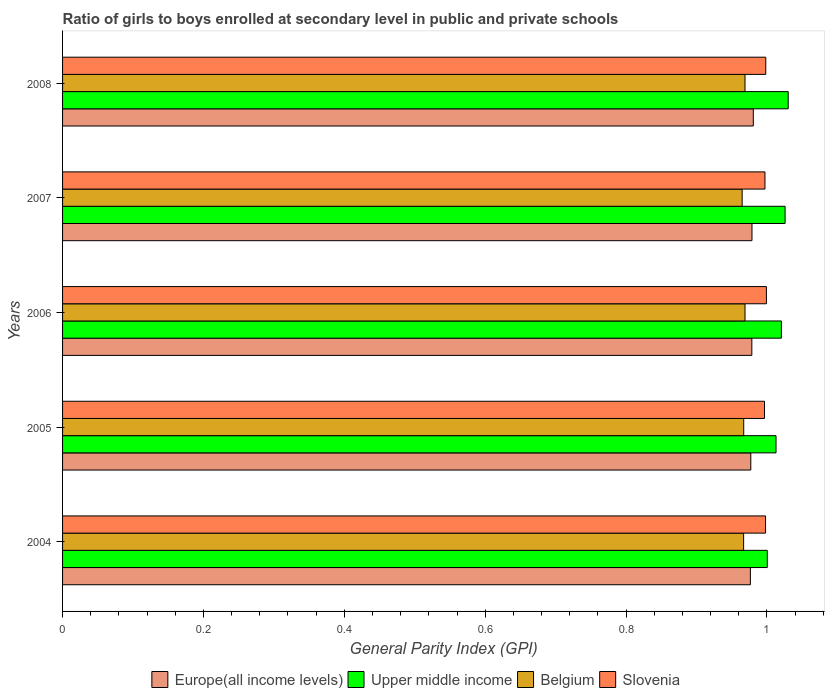How many groups of bars are there?
Keep it short and to the point. 5. Are the number of bars per tick equal to the number of legend labels?
Ensure brevity in your answer.  Yes. Are the number of bars on each tick of the Y-axis equal?
Offer a very short reply. Yes. What is the general parity index in Upper middle income in 2004?
Make the answer very short. 1. Across all years, what is the maximum general parity index in Slovenia?
Keep it short and to the point. 1. Across all years, what is the minimum general parity index in Upper middle income?
Keep it short and to the point. 1. In which year was the general parity index in Europe(all income levels) maximum?
Offer a terse response. 2008. In which year was the general parity index in Slovenia minimum?
Make the answer very short. 2005. What is the total general parity index in Slovenia in the graph?
Offer a very short reply. 4.99. What is the difference between the general parity index in Europe(all income levels) in 2004 and that in 2006?
Your response must be concise. -0. What is the difference between the general parity index in Europe(all income levels) in 2004 and the general parity index in Belgium in 2008?
Give a very brief answer. 0.01. What is the average general parity index in Europe(all income levels) per year?
Make the answer very short. 0.98. In the year 2006, what is the difference between the general parity index in Slovenia and general parity index in Upper middle income?
Offer a terse response. -0.02. In how many years, is the general parity index in Upper middle income greater than 0.48000000000000004 ?
Your answer should be very brief. 5. What is the ratio of the general parity index in Upper middle income in 2004 to that in 2006?
Your response must be concise. 0.98. What is the difference between the highest and the second highest general parity index in Belgium?
Your answer should be compact. 1.996755599986688e-5. What is the difference between the highest and the lowest general parity index in Slovenia?
Give a very brief answer. 0. Is the sum of the general parity index in Europe(all income levels) in 2005 and 2006 greater than the maximum general parity index in Belgium across all years?
Offer a terse response. Yes. Is it the case that in every year, the sum of the general parity index in Belgium and general parity index in Upper middle income is greater than the sum of general parity index in Slovenia and general parity index in Europe(all income levels)?
Give a very brief answer. No. What does the 1st bar from the top in 2008 represents?
Give a very brief answer. Slovenia. What does the 3rd bar from the bottom in 2006 represents?
Offer a terse response. Belgium. Is it the case that in every year, the sum of the general parity index in Slovenia and general parity index in Upper middle income is greater than the general parity index in Europe(all income levels)?
Your answer should be very brief. Yes. How are the legend labels stacked?
Provide a short and direct response. Horizontal. What is the title of the graph?
Provide a short and direct response. Ratio of girls to boys enrolled at secondary level in public and private schools. Does "Uzbekistan" appear as one of the legend labels in the graph?
Provide a succinct answer. No. What is the label or title of the X-axis?
Offer a terse response. General Parity Index (GPI). What is the label or title of the Y-axis?
Provide a succinct answer. Years. What is the General Parity Index (GPI) in Europe(all income levels) in 2004?
Provide a succinct answer. 0.98. What is the General Parity Index (GPI) in Upper middle income in 2004?
Make the answer very short. 1. What is the General Parity Index (GPI) in Belgium in 2004?
Offer a terse response. 0.97. What is the General Parity Index (GPI) of Slovenia in 2004?
Offer a very short reply. 1. What is the General Parity Index (GPI) in Europe(all income levels) in 2005?
Offer a very short reply. 0.98. What is the General Parity Index (GPI) in Upper middle income in 2005?
Your answer should be very brief. 1.01. What is the General Parity Index (GPI) in Belgium in 2005?
Give a very brief answer. 0.97. What is the General Parity Index (GPI) in Slovenia in 2005?
Provide a short and direct response. 1. What is the General Parity Index (GPI) of Europe(all income levels) in 2006?
Offer a terse response. 0.98. What is the General Parity Index (GPI) in Upper middle income in 2006?
Offer a terse response. 1.02. What is the General Parity Index (GPI) in Belgium in 2006?
Provide a succinct answer. 0.97. What is the General Parity Index (GPI) of Slovenia in 2006?
Your response must be concise. 1. What is the General Parity Index (GPI) in Europe(all income levels) in 2007?
Your response must be concise. 0.98. What is the General Parity Index (GPI) in Upper middle income in 2007?
Make the answer very short. 1.03. What is the General Parity Index (GPI) in Belgium in 2007?
Your response must be concise. 0.96. What is the General Parity Index (GPI) in Slovenia in 2007?
Ensure brevity in your answer.  1. What is the General Parity Index (GPI) in Europe(all income levels) in 2008?
Offer a very short reply. 0.98. What is the General Parity Index (GPI) in Upper middle income in 2008?
Make the answer very short. 1.03. What is the General Parity Index (GPI) of Belgium in 2008?
Your answer should be compact. 0.97. What is the General Parity Index (GPI) of Slovenia in 2008?
Keep it short and to the point. 1. Across all years, what is the maximum General Parity Index (GPI) of Europe(all income levels)?
Make the answer very short. 0.98. Across all years, what is the maximum General Parity Index (GPI) of Upper middle income?
Make the answer very short. 1.03. Across all years, what is the maximum General Parity Index (GPI) in Belgium?
Your answer should be compact. 0.97. Across all years, what is the maximum General Parity Index (GPI) of Slovenia?
Keep it short and to the point. 1. Across all years, what is the minimum General Parity Index (GPI) of Europe(all income levels)?
Offer a terse response. 0.98. Across all years, what is the minimum General Parity Index (GPI) of Upper middle income?
Provide a short and direct response. 1. Across all years, what is the minimum General Parity Index (GPI) of Belgium?
Offer a terse response. 0.96. Across all years, what is the minimum General Parity Index (GPI) of Slovenia?
Make the answer very short. 1. What is the total General Parity Index (GPI) in Europe(all income levels) in the graph?
Make the answer very short. 4.89. What is the total General Parity Index (GPI) of Upper middle income in the graph?
Ensure brevity in your answer.  5.09. What is the total General Parity Index (GPI) in Belgium in the graph?
Your answer should be very brief. 4.84. What is the total General Parity Index (GPI) in Slovenia in the graph?
Offer a terse response. 4.99. What is the difference between the General Parity Index (GPI) in Europe(all income levels) in 2004 and that in 2005?
Offer a terse response. -0. What is the difference between the General Parity Index (GPI) in Upper middle income in 2004 and that in 2005?
Provide a succinct answer. -0.01. What is the difference between the General Parity Index (GPI) in Belgium in 2004 and that in 2005?
Your response must be concise. -0. What is the difference between the General Parity Index (GPI) in Slovenia in 2004 and that in 2005?
Provide a succinct answer. 0. What is the difference between the General Parity Index (GPI) of Europe(all income levels) in 2004 and that in 2006?
Offer a very short reply. -0. What is the difference between the General Parity Index (GPI) of Upper middle income in 2004 and that in 2006?
Make the answer very short. -0.02. What is the difference between the General Parity Index (GPI) of Belgium in 2004 and that in 2006?
Your answer should be very brief. -0. What is the difference between the General Parity Index (GPI) in Slovenia in 2004 and that in 2006?
Provide a short and direct response. -0. What is the difference between the General Parity Index (GPI) of Europe(all income levels) in 2004 and that in 2007?
Offer a terse response. -0. What is the difference between the General Parity Index (GPI) of Upper middle income in 2004 and that in 2007?
Give a very brief answer. -0.03. What is the difference between the General Parity Index (GPI) of Belgium in 2004 and that in 2007?
Offer a terse response. 0. What is the difference between the General Parity Index (GPI) in Slovenia in 2004 and that in 2007?
Give a very brief answer. 0. What is the difference between the General Parity Index (GPI) in Europe(all income levels) in 2004 and that in 2008?
Offer a terse response. -0. What is the difference between the General Parity Index (GPI) of Upper middle income in 2004 and that in 2008?
Offer a terse response. -0.03. What is the difference between the General Parity Index (GPI) of Belgium in 2004 and that in 2008?
Your answer should be compact. -0. What is the difference between the General Parity Index (GPI) of Slovenia in 2004 and that in 2008?
Your answer should be compact. -0. What is the difference between the General Parity Index (GPI) in Europe(all income levels) in 2005 and that in 2006?
Give a very brief answer. -0. What is the difference between the General Parity Index (GPI) in Upper middle income in 2005 and that in 2006?
Keep it short and to the point. -0.01. What is the difference between the General Parity Index (GPI) in Belgium in 2005 and that in 2006?
Give a very brief answer. -0. What is the difference between the General Parity Index (GPI) of Slovenia in 2005 and that in 2006?
Your answer should be compact. -0. What is the difference between the General Parity Index (GPI) in Europe(all income levels) in 2005 and that in 2007?
Provide a short and direct response. -0. What is the difference between the General Parity Index (GPI) of Upper middle income in 2005 and that in 2007?
Your answer should be compact. -0.01. What is the difference between the General Parity Index (GPI) in Belgium in 2005 and that in 2007?
Keep it short and to the point. 0. What is the difference between the General Parity Index (GPI) of Slovenia in 2005 and that in 2007?
Give a very brief answer. -0. What is the difference between the General Parity Index (GPI) of Europe(all income levels) in 2005 and that in 2008?
Keep it short and to the point. -0. What is the difference between the General Parity Index (GPI) of Upper middle income in 2005 and that in 2008?
Provide a short and direct response. -0.02. What is the difference between the General Parity Index (GPI) in Belgium in 2005 and that in 2008?
Ensure brevity in your answer.  -0. What is the difference between the General Parity Index (GPI) of Slovenia in 2005 and that in 2008?
Keep it short and to the point. -0. What is the difference between the General Parity Index (GPI) in Europe(all income levels) in 2006 and that in 2007?
Keep it short and to the point. -0. What is the difference between the General Parity Index (GPI) in Upper middle income in 2006 and that in 2007?
Ensure brevity in your answer.  -0.01. What is the difference between the General Parity Index (GPI) of Belgium in 2006 and that in 2007?
Your answer should be compact. 0. What is the difference between the General Parity Index (GPI) of Slovenia in 2006 and that in 2007?
Give a very brief answer. 0. What is the difference between the General Parity Index (GPI) in Europe(all income levels) in 2006 and that in 2008?
Make the answer very short. -0. What is the difference between the General Parity Index (GPI) of Upper middle income in 2006 and that in 2008?
Offer a terse response. -0.01. What is the difference between the General Parity Index (GPI) of Belgium in 2006 and that in 2008?
Your answer should be very brief. 0. What is the difference between the General Parity Index (GPI) of Slovenia in 2006 and that in 2008?
Provide a succinct answer. 0. What is the difference between the General Parity Index (GPI) in Europe(all income levels) in 2007 and that in 2008?
Make the answer very short. -0. What is the difference between the General Parity Index (GPI) of Upper middle income in 2007 and that in 2008?
Your answer should be very brief. -0. What is the difference between the General Parity Index (GPI) in Belgium in 2007 and that in 2008?
Provide a short and direct response. -0. What is the difference between the General Parity Index (GPI) in Slovenia in 2007 and that in 2008?
Provide a succinct answer. -0. What is the difference between the General Parity Index (GPI) in Europe(all income levels) in 2004 and the General Parity Index (GPI) in Upper middle income in 2005?
Offer a terse response. -0.04. What is the difference between the General Parity Index (GPI) in Europe(all income levels) in 2004 and the General Parity Index (GPI) in Belgium in 2005?
Your answer should be very brief. 0.01. What is the difference between the General Parity Index (GPI) of Europe(all income levels) in 2004 and the General Parity Index (GPI) of Slovenia in 2005?
Keep it short and to the point. -0.02. What is the difference between the General Parity Index (GPI) in Upper middle income in 2004 and the General Parity Index (GPI) in Belgium in 2005?
Your answer should be very brief. 0.03. What is the difference between the General Parity Index (GPI) of Upper middle income in 2004 and the General Parity Index (GPI) of Slovenia in 2005?
Keep it short and to the point. 0. What is the difference between the General Parity Index (GPI) of Belgium in 2004 and the General Parity Index (GPI) of Slovenia in 2005?
Provide a succinct answer. -0.03. What is the difference between the General Parity Index (GPI) of Europe(all income levels) in 2004 and the General Parity Index (GPI) of Upper middle income in 2006?
Your response must be concise. -0.04. What is the difference between the General Parity Index (GPI) in Europe(all income levels) in 2004 and the General Parity Index (GPI) in Belgium in 2006?
Offer a very short reply. 0.01. What is the difference between the General Parity Index (GPI) of Europe(all income levels) in 2004 and the General Parity Index (GPI) of Slovenia in 2006?
Make the answer very short. -0.02. What is the difference between the General Parity Index (GPI) of Upper middle income in 2004 and the General Parity Index (GPI) of Belgium in 2006?
Ensure brevity in your answer.  0.03. What is the difference between the General Parity Index (GPI) in Upper middle income in 2004 and the General Parity Index (GPI) in Slovenia in 2006?
Your answer should be compact. 0. What is the difference between the General Parity Index (GPI) in Belgium in 2004 and the General Parity Index (GPI) in Slovenia in 2006?
Your response must be concise. -0.03. What is the difference between the General Parity Index (GPI) of Europe(all income levels) in 2004 and the General Parity Index (GPI) of Upper middle income in 2007?
Your answer should be compact. -0.05. What is the difference between the General Parity Index (GPI) of Europe(all income levels) in 2004 and the General Parity Index (GPI) of Belgium in 2007?
Your answer should be compact. 0.01. What is the difference between the General Parity Index (GPI) in Europe(all income levels) in 2004 and the General Parity Index (GPI) in Slovenia in 2007?
Provide a short and direct response. -0.02. What is the difference between the General Parity Index (GPI) of Upper middle income in 2004 and the General Parity Index (GPI) of Belgium in 2007?
Give a very brief answer. 0.04. What is the difference between the General Parity Index (GPI) of Upper middle income in 2004 and the General Parity Index (GPI) of Slovenia in 2007?
Provide a short and direct response. 0. What is the difference between the General Parity Index (GPI) of Belgium in 2004 and the General Parity Index (GPI) of Slovenia in 2007?
Provide a succinct answer. -0.03. What is the difference between the General Parity Index (GPI) in Europe(all income levels) in 2004 and the General Parity Index (GPI) in Upper middle income in 2008?
Keep it short and to the point. -0.05. What is the difference between the General Parity Index (GPI) of Europe(all income levels) in 2004 and the General Parity Index (GPI) of Belgium in 2008?
Your response must be concise. 0.01. What is the difference between the General Parity Index (GPI) of Europe(all income levels) in 2004 and the General Parity Index (GPI) of Slovenia in 2008?
Keep it short and to the point. -0.02. What is the difference between the General Parity Index (GPI) of Upper middle income in 2004 and the General Parity Index (GPI) of Belgium in 2008?
Make the answer very short. 0.03. What is the difference between the General Parity Index (GPI) in Upper middle income in 2004 and the General Parity Index (GPI) in Slovenia in 2008?
Offer a terse response. 0. What is the difference between the General Parity Index (GPI) of Belgium in 2004 and the General Parity Index (GPI) of Slovenia in 2008?
Make the answer very short. -0.03. What is the difference between the General Parity Index (GPI) of Europe(all income levels) in 2005 and the General Parity Index (GPI) of Upper middle income in 2006?
Your response must be concise. -0.04. What is the difference between the General Parity Index (GPI) in Europe(all income levels) in 2005 and the General Parity Index (GPI) in Belgium in 2006?
Provide a short and direct response. 0.01. What is the difference between the General Parity Index (GPI) of Europe(all income levels) in 2005 and the General Parity Index (GPI) of Slovenia in 2006?
Make the answer very short. -0.02. What is the difference between the General Parity Index (GPI) in Upper middle income in 2005 and the General Parity Index (GPI) in Belgium in 2006?
Keep it short and to the point. 0.04. What is the difference between the General Parity Index (GPI) of Upper middle income in 2005 and the General Parity Index (GPI) of Slovenia in 2006?
Your answer should be very brief. 0.01. What is the difference between the General Parity Index (GPI) in Belgium in 2005 and the General Parity Index (GPI) in Slovenia in 2006?
Your answer should be very brief. -0.03. What is the difference between the General Parity Index (GPI) in Europe(all income levels) in 2005 and the General Parity Index (GPI) in Upper middle income in 2007?
Your response must be concise. -0.05. What is the difference between the General Parity Index (GPI) in Europe(all income levels) in 2005 and the General Parity Index (GPI) in Belgium in 2007?
Offer a terse response. 0.01. What is the difference between the General Parity Index (GPI) of Europe(all income levels) in 2005 and the General Parity Index (GPI) of Slovenia in 2007?
Offer a very short reply. -0.02. What is the difference between the General Parity Index (GPI) in Upper middle income in 2005 and the General Parity Index (GPI) in Belgium in 2007?
Your answer should be compact. 0.05. What is the difference between the General Parity Index (GPI) in Upper middle income in 2005 and the General Parity Index (GPI) in Slovenia in 2007?
Your answer should be compact. 0.02. What is the difference between the General Parity Index (GPI) in Belgium in 2005 and the General Parity Index (GPI) in Slovenia in 2007?
Offer a very short reply. -0.03. What is the difference between the General Parity Index (GPI) of Europe(all income levels) in 2005 and the General Parity Index (GPI) of Upper middle income in 2008?
Provide a short and direct response. -0.05. What is the difference between the General Parity Index (GPI) of Europe(all income levels) in 2005 and the General Parity Index (GPI) of Belgium in 2008?
Give a very brief answer. 0.01. What is the difference between the General Parity Index (GPI) in Europe(all income levels) in 2005 and the General Parity Index (GPI) in Slovenia in 2008?
Keep it short and to the point. -0.02. What is the difference between the General Parity Index (GPI) of Upper middle income in 2005 and the General Parity Index (GPI) of Belgium in 2008?
Ensure brevity in your answer.  0.04. What is the difference between the General Parity Index (GPI) of Upper middle income in 2005 and the General Parity Index (GPI) of Slovenia in 2008?
Give a very brief answer. 0.01. What is the difference between the General Parity Index (GPI) in Belgium in 2005 and the General Parity Index (GPI) in Slovenia in 2008?
Your answer should be very brief. -0.03. What is the difference between the General Parity Index (GPI) of Europe(all income levels) in 2006 and the General Parity Index (GPI) of Upper middle income in 2007?
Your answer should be compact. -0.05. What is the difference between the General Parity Index (GPI) of Europe(all income levels) in 2006 and the General Parity Index (GPI) of Belgium in 2007?
Your answer should be very brief. 0.01. What is the difference between the General Parity Index (GPI) in Europe(all income levels) in 2006 and the General Parity Index (GPI) in Slovenia in 2007?
Provide a succinct answer. -0.02. What is the difference between the General Parity Index (GPI) of Upper middle income in 2006 and the General Parity Index (GPI) of Belgium in 2007?
Offer a very short reply. 0.06. What is the difference between the General Parity Index (GPI) in Upper middle income in 2006 and the General Parity Index (GPI) in Slovenia in 2007?
Offer a very short reply. 0.02. What is the difference between the General Parity Index (GPI) in Belgium in 2006 and the General Parity Index (GPI) in Slovenia in 2007?
Provide a short and direct response. -0.03. What is the difference between the General Parity Index (GPI) of Europe(all income levels) in 2006 and the General Parity Index (GPI) of Upper middle income in 2008?
Your answer should be very brief. -0.05. What is the difference between the General Parity Index (GPI) in Europe(all income levels) in 2006 and the General Parity Index (GPI) in Belgium in 2008?
Give a very brief answer. 0.01. What is the difference between the General Parity Index (GPI) of Europe(all income levels) in 2006 and the General Parity Index (GPI) of Slovenia in 2008?
Provide a succinct answer. -0.02. What is the difference between the General Parity Index (GPI) in Upper middle income in 2006 and the General Parity Index (GPI) in Belgium in 2008?
Make the answer very short. 0.05. What is the difference between the General Parity Index (GPI) in Upper middle income in 2006 and the General Parity Index (GPI) in Slovenia in 2008?
Provide a short and direct response. 0.02. What is the difference between the General Parity Index (GPI) in Belgium in 2006 and the General Parity Index (GPI) in Slovenia in 2008?
Provide a succinct answer. -0.03. What is the difference between the General Parity Index (GPI) of Europe(all income levels) in 2007 and the General Parity Index (GPI) of Upper middle income in 2008?
Provide a succinct answer. -0.05. What is the difference between the General Parity Index (GPI) in Europe(all income levels) in 2007 and the General Parity Index (GPI) in Belgium in 2008?
Provide a succinct answer. 0.01. What is the difference between the General Parity Index (GPI) of Europe(all income levels) in 2007 and the General Parity Index (GPI) of Slovenia in 2008?
Your answer should be very brief. -0.02. What is the difference between the General Parity Index (GPI) of Upper middle income in 2007 and the General Parity Index (GPI) of Belgium in 2008?
Provide a short and direct response. 0.06. What is the difference between the General Parity Index (GPI) of Upper middle income in 2007 and the General Parity Index (GPI) of Slovenia in 2008?
Provide a short and direct response. 0.03. What is the difference between the General Parity Index (GPI) in Belgium in 2007 and the General Parity Index (GPI) in Slovenia in 2008?
Offer a very short reply. -0.03. What is the average General Parity Index (GPI) in Europe(all income levels) per year?
Offer a very short reply. 0.98. What is the average General Parity Index (GPI) in Upper middle income per year?
Ensure brevity in your answer.  1.02. What is the average General Parity Index (GPI) in Belgium per year?
Keep it short and to the point. 0.97. What is the average General Parity Index (GPI) of Slovenia per year?
Provide a short and direct response. 1. In the year 2004, what is the difference between the General Parity Index (GPI) in Europe(all income levels) and General Parity Index (GPI) in Upper middle income?
Your response must be concise. -0.02. In the year 2004, what is the difference between the General Parity Index (GPI) in Europe(all income levels) and General Parity Index (GPI) in Belgium?
Your answer should be very brief. 0.01. In the year 2004, what is the difference between the General Parity Index (GPI) in Europe(all income levels) and General Parity Index (GPI) in Slovenia?
Provide a short and direct response. -0.02. In the year 2004, what is the difference between the General Parity Index (GPI) of Upper middle income and General Parity Index (GPI) of Belgium?
Provide a succinct answer. 0.03. In the year 2004, what is the difference between the General Parity Index (GPI) of Upper middle income and General Parity Index (GPI) of Slovenia?
Keep it short and to the point. 0. In the year 2004, what is the difference between the General Parity Index (GPI) in Belgium and General Parity Index (GPI) in Slovenia?
Offer a terse response. -0.03. In the year 2005, what is the difference between the General Parity Index (GPI) of Europe(all income levels) and General Parity Index (GPI) of Upper middle income?
Provide a succinct answer. -0.04. In the year 2005, what is the difference between the General Parity Index (GPI) of Europe(all income levels) and General Parity Index (GPI) of Belgium?
Make the answer very short. 0.01. In the year 2005, what is the difference between the General Parity Index (GPI) in Europe(all income levels) and General Parity Index (GPI) in Slovenia?
Your answer should be very brief. -0.02. In the year 2005, what is the difference between the General Parity Index (GPI) in Upper middle income and General Parity Index (GPI) in Belgium?
Make the answer very short. 0.05. In the year 2005, what is the difference between the General Parity Index (GPI) in Upper middle income and General Parity Index (GPI) in Slovenia?
Offer a very short reply. 0.02. In the year 2005, what is the difference between the General Parity Index (GPI) of Belgium and General Parity Index (GPI) of Slovenia?
Offer a very short reply. -0.03. In the year 2006, what is the difference between the General Parity Index (GPI) in Europe(all income levels) and General Parity Index (GPI) in Upper middle income?
Offer a terse response. -0.04. In the year 2006, what is the difference between the General Parity Index (GPI) in Europe(all income levels) and General Parity Index (GPI) in Belgium?
Your response must be concise. 0.01. In the year 2006, what is the difference between the General Parity Index (GPI) in Europe(all income levels) and General Parity Index (GPI) in Slovenia?
Provide a succinct answer. -0.02. In the year 2006, what is the difference between the General Parity Index (GPI) in Upper middle income and General Parity Index (GPI) in Belgium?
Your answer should be compact. 0.05. In the year 2006, what is the difference between the General Parity Index (GPI) of Upper middle income and General Parity Index (GPI) of Slovenia?
Offer a terse response. 0.02. In the year 2006, what is the difference between the General Parity Index (GPI) of Belgium and General Parity Index (GPI) of Slovenia?
Give a very brief answer. -0.03. In the year 2007, what is the difference between the General Parity Index (GPI) in Europe(all income levels) and General Parity Index (GPI) in Upper middle income?
Your answer should be very brief. -0.05. In the year 2007, what is the difference between the General Parity Index (GPI) of Europe(all income levels) and General Parity Index (GPI) of Belgium?
Provide a short and direct response. 0.01. In the year 2007, what is the difference between the General Parity Index (GPI) in Europe(all income levels) and General Parity Index (GPI) in Slovenia?
Your answer should be compact. -0.02. In the year 2007, what is the difference between the General Parity Index (GPI) in Upper middle income and General Parity Index (GPI) in Belgium?
Your response must be concise. 0.06. In the year 2007, what is the difference between the General Parity Index (GPI) in Upper middle income and General Parity Index (GPI) in Slovenia?
Your answer should be compact. 0.03. In the year 2007, what is the difference between the General Parity Index (GPI) in Belgium and General Parity Index (GPI) in Slovenia?
Offer a very short reply. -0.03. In the year 2008, what is the difference between the General Parity Index (GPI) of Europe(all income levels) and General Parity Index (GPI) of Upper middle income?
Offer a terse response. -0.05. In the year 2008, what is the difference between the General Parity Index (GPI) of Europe(all income levels) and General Parity Index (GPI) of Belgium?
Your response must be concise. 0.01. In the year 2008, what is the difference between the General Parity Index (GPI) in Europe(all income levels) and General Parity Index (GPI) in Slovenia?
Give a very brief answer. -0.02. In the year 2008, what is the difference between the General Parity Index (GPI) in Upper middle income and General Parity Index (GPI) in Belgium?
Offer a terse response. 0.06. In the year 2008, what is the difference between the General Parity Index (GPI) of Upper middle income and General Parity Index (GPI) of Slovenia?
Offer a terse response. 0.03. In the year 2008, what is the difference between the General Parity Index (GPI) of Belgium and General Parity Index (GPI) of Slovenia?
Offer a terse response. -0.03. What is the ratio of the General Parity Index (GPI) in Upper middle income in 2004 to that in 2005?
Ensure brevity in your answer.  0.99. What is the ratio of the General Parity Index (GPI) in Belgium in 2004 to that in 2005?
Offer a very short reply. 1. What is the ratio of the General Parity Index (GPI) in Upper middle income in 2004 to that in 2006?
Provide a succinct answer. 0.98. What is the ratio of the General Parity Index (GPI) in Slovenia in 2004 to that in 2006?
Make the answer very short. 1. What is the ratio of the General Parity Index (GPI) in Europe(all income levels) in 2004 to that in 2007?
Your answer should be very brief. 1. What is the ratio of the General Parity Index (GPI) of Upper middle income in 2004 to that in 2007?
Keep it short and to the point. 0.98. What is the ratio of the General Parity Index (GPI) in Belgium in 2004 to that in 2007?
Offer a terse response. 1. What is the ratio of the General Parity Index (GPI) in Upper middle income in 2004 to that in 2008?
Your response must be concise. 0.97. What is the ratio of the General Parity Index (GPI) in Slovenia in 2004 to that in 2008?
Give a very brief answer. 1. What is the ratio of the General Parity Index (GPI) of Europe(all income levels) in 2005 to that in 2006?
Offer a terse response. 1. What is the ratio of the General Parity Index (GPI) of Belgium in 2005 to that in 2006?
Keep it short and to the point. 1. What is the ratio of the General Parity Index (GPI) in Upper middle income in 2005 to that in 2007?
Provide a short and direct response. 0.99. What is the ratio of the General Parity Index (GPI) in Upper middle income in 2005 to that in 2008?
Offer a very short reply. 0.98. What is the ratio of the General Parity Index (GPI) in Slovenia in 2005 to that in 2008?
Offer a terse response. 1. What is the ratio of the General Parity Index (GPI) in Europe(all income levels) in 2006 to that in 2007?
Provide a short and direct response. 1. What is the ratio of the General Parity Index (GPI) of Upper middle income in 2006 to that in 2007?
Your answer should be compact. 0.99. What is the ratio of the General Parity Index (GPI) of Slovenia in 2006 to that in 2007?
Keep it short and to the point. 1. What is the ratio of the General Parity Index (GPI) of Europe(all income levels) in 2006 to that in 2008?
Give a very brief answer. 1. What is the ratio of the General Parity Index (GPI) of Upper middle income in 2006 to that in 2008?
Provide a succinct answer. 0.99. What is the ratio of the General Parity Index (GPI) of Belgium in 2006 to that in 2008?
Your answer should be compact. 1. What is the ratio of the General Parity Index (GPI) in Slovenia in 2006 to that in 2008?
Your response must be concise. 1. What is the ratio of the General Parity Index (GPI) in Belgium in 2007 to that in 2008?
Your answer should be compact. 1. What is the difference between the highest and the second highest General Parity Index (GPI) in Europe(all income levels)?
Your response must be concise. 0. What is the difference between the highest and the second highest General Parity Index (GPI) of Upper middle income?
Offer a very short reply. 0. What is the difference between the highest and the second highest General Parity Index (GPI) in Belgium?
Provide a succinct answer. 0. What is the difference between the highest and the second highest General Parity Index (GPI) in Slovenia?
Make the answer very short. 0. What is the difference between the highest and the lowest General Parity Index (GPI) of Europe(all income levels)?
Ensure brevity in your answer.  0. What is the difference between the highest and the lowest General Parity Index (GPI) in Upper middle income?
Offer a very short reply. 0.03. What is the difference between the highest and the lowest General Parity Index (GPI) in Belgium?
Provide a short and direct response. 0. What is the difference between the highest and the lowest General Parity Index (GPI) in Slovenia?
Offer a terse response. 0. 